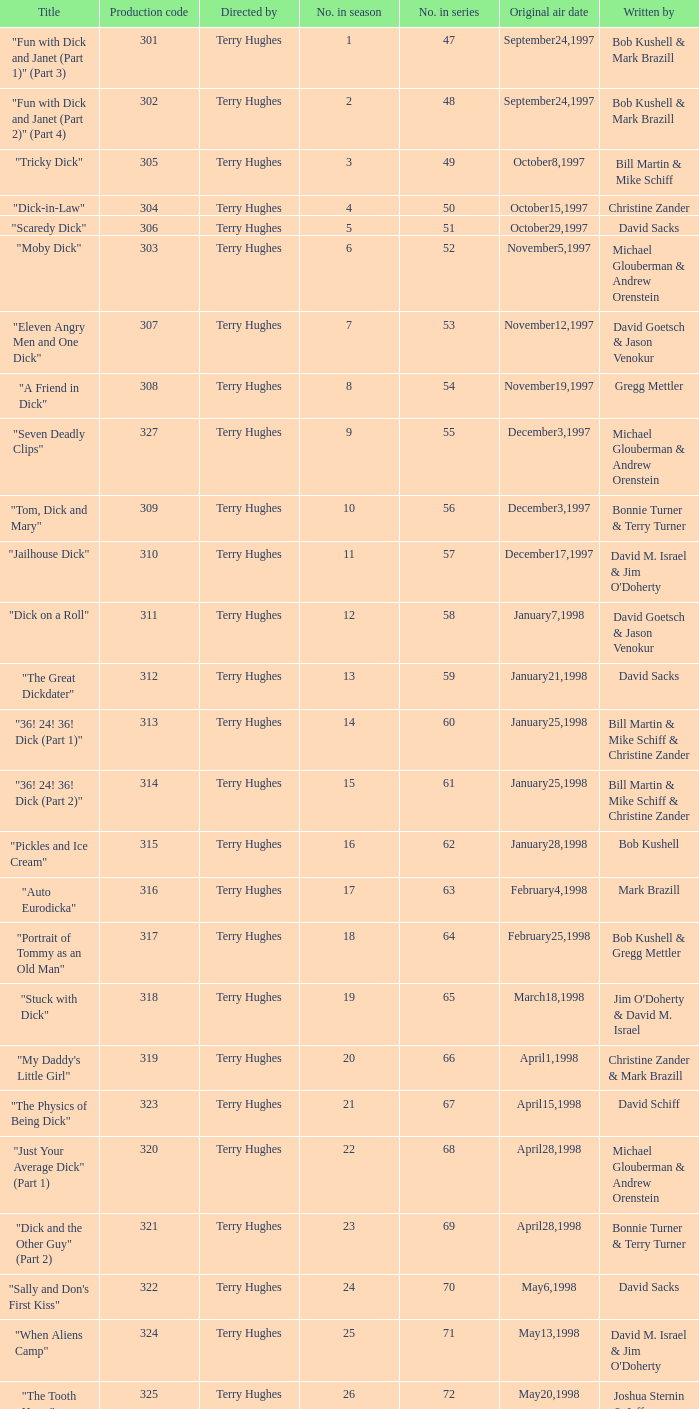Could you help me parse every detail presented in this table? {'header': ['Title', 'Production code', 'Directed by', 'No. in season', 'No. in series', 'Original air date', 'Written by'], 'rows': [['"Fun with Dick and Janet (Part 1)" (Part 3)', '301', 'Terry Hughes', '1', '47', 'September24,1997', 'Bob Kushell & Mark Brazill'], ['"Fun with Dick and Janet (Part 2)" (Part 4)', '302', 'Terry Hughes', '2', '48', 'September24,1997', 'Bob Kushell & Mark Brazill'], ['"Tricky Dick"', '305', 'Terry Hughes', '3', '49', 'October8,1997', 'Bill Martin & Mike Schiff'], ['"Dick-in-Law"', '304', 'Terry Hughes', '4', '50', 'October15,1997', 'Christine Zander'], ['"Scaredy Dick"', '306', 'Terry Hughes', '5', '51', 'October29,1997', 'David Sacks'], ['"Moby Dick"', '303', 'Terry Hughes', '6', '52', 'November5,1997', 'Michael Glouberman & Andrew Orenstein'], ['"Eleven Angry Men and One Dick"', '307', 'Terry Hughes', '7', '53', 'November12,1997', 'David Goetsch & Jason Venokur'], ['"A Friend in Dick"', '308', 'Terry Hughes', '8', '54', 'November19,1997', 'Gregg Mettler'], ['"Seven Deadly Clips"', '327', 'Terry Hughes', '9', '55', 'December3,1997', 'Michael Glouberman & Andrew Orenstein'], ['"Tom, Dick and Mary"', '309', 'Terry Hughes', '10', '56', 'December3,1997', 'Bonnie Turner & Terry Turner'], ['"Jailhouse Dick"', '310', 'Terry Hughes', '11', '57', 'December17,1997', "David M. Israel & Jim O'Doherty"], ['"Dick on a Roll"', '311', 'Terry Hughes', '12', '58', 'January7,1998', 'David Goetsch & Jason Venokur'], ['"The Great Dickdater"', '312', 'Terry Hughes', '13', '59', 'January21,1998', 'David Sacks'], ['"36! 24! 36! Dick (Part 1)"', '313', 'Terry Hughes', '14', '60', 'January25,1998', 'Bill Martin & Mike Schiff & Christine Zander'], ['"36! 24! 36! Dick (Part 2)"', '314', 'Terry Hughes', '15', '61', 'January25,1998', 'Bill Martin & Mike Schiff & Christine Zander'], ['"Pickles and Ice Cream"', '315', 'Terry Hughes', '16', '62', 'January28,1998', 'Bob Kushell'], ['"Auto Eurodicka"', '316', 'Terry Hughes', '17', '63', 'February4,1998', 'Mark Brazill'], ['"Portrait of Tommy as an Old Man"', '317', 'Terry Hughes', '18', '64', 'February25,1998', 'Bob Kushell & Gregg Mettler'], ['"Stuck with Dick"', '318', 'Terry Hughes', '19', '65', 'March18,1998', "Jim O'Doherty & David M. Israel"], ['"My Daddy\'s Little Girl"', '319', 'Terry Hughes', '20', '66', 'April1,1998', 'Christine Zander & Mark Brazill'], ['"The Physics of Being Dick"', '323', 'Terry Hughes', '21', '67', 'April15,1998', 'David Schiff'], ['"Just Your Average Dick" (Part 1)', '320', 'Terry Hughes', '22', '68', 'April28,1998', 'Michael Glouberman & Andrew Orenstein'], ['"Dick and the Other Guy" (Part 2)', '321', 'Terry Hughes', '23', '69', 'April28,1998', 'Bonnie Turner & Terry Turner'], ['"Sally and Don\'s First Kiss"', '322', 'Terry Hughes', '24', '70', 'May6,1998', 'David Sacks'], ['"When Aliens Camp"', '324', 'Terry Hughes', '25', '71', 'May13,1998', "David M. Israel & Jim O'Doherty"], ['"The Tooth Harry"', '325', 'Terry Hughes', '26', '72', 'May20,1998', 'Joshua Sternin & Jeffrey Ventimilia']]} What is the title of episode 10? "Tom, Dick and Mary". 